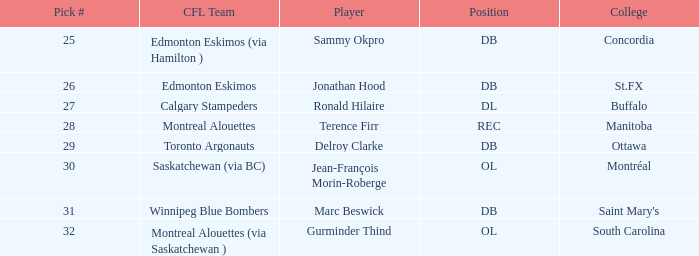What is buffalo's selection number? 27.0. 